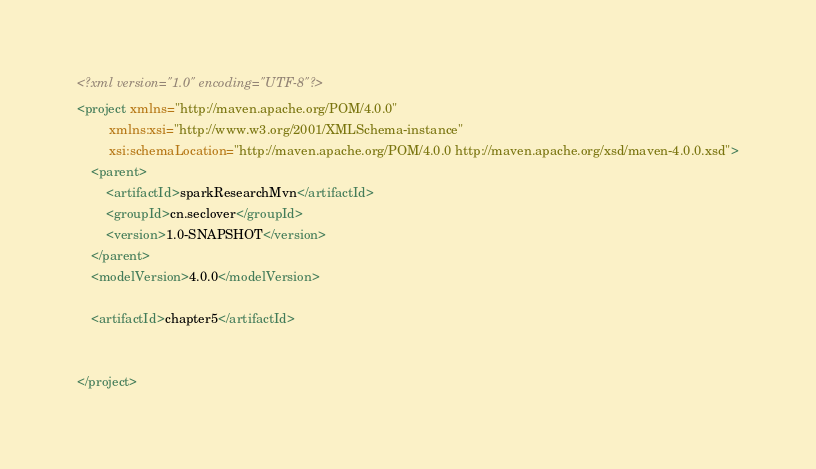Convert code to text. <code><loc_0><loc_0><loc_500><loc_500><_XML_><?xml version="1.0" encoding="UTF-8"?>
<project xmlns="http://maven.apache.org/POM/4.0.0"
         xmlns:xsi="http://www.w3.org/2001/XMLSchema-instance"
         xsi:schemaLocation="http://maven.apache.org/POM/4.0.0 http://maven.apache.org/xsd/maven-4.0.0.xsd">
    <parent>
        <artifactId>sparkResearchMvn</artifactId>
        <groupId>cn.seclover</groupId>
        <version>1.0-SNAPSHOT</version>
    </parent>
    <modelVersion>4.0.0</modelVersion>

    <artifactId>chapter5</artifactId>


</project></code> 